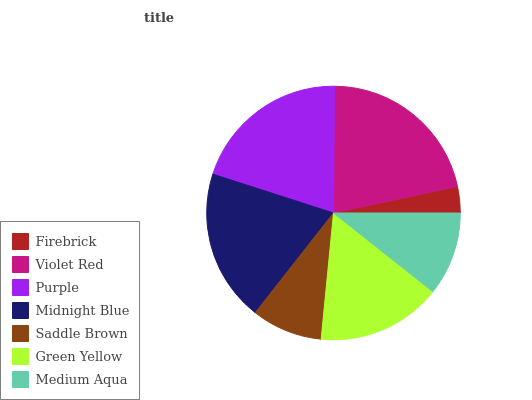Is Firebrick the minimum?
Answer yes or no. Yes. Is Violet Red the maximum?
Answer yes or no. Yes. Is Purple the minimum?
Answer yes or no. No. Is Purple the maximum?
Answer yes or no. No. Is Violet Red greater than Purple?
Answer yes or no. Yes. Is Purple less than Violet Red?
Answer yes or no. Yes. Is Purple greater than Violet Red?
Answer yes or no. No. Is Violet Red less than Purple?
Answer yes or no. No. Is Green Yellow the high median?
Answer yes or no. Yes. Is Green Yellow the low median?
Answer yes or no. Yes. Is Medium Aqua the high median?
Answer yes or no. No. Is Midnight Blue the low median?
Answer yes or no. No. 